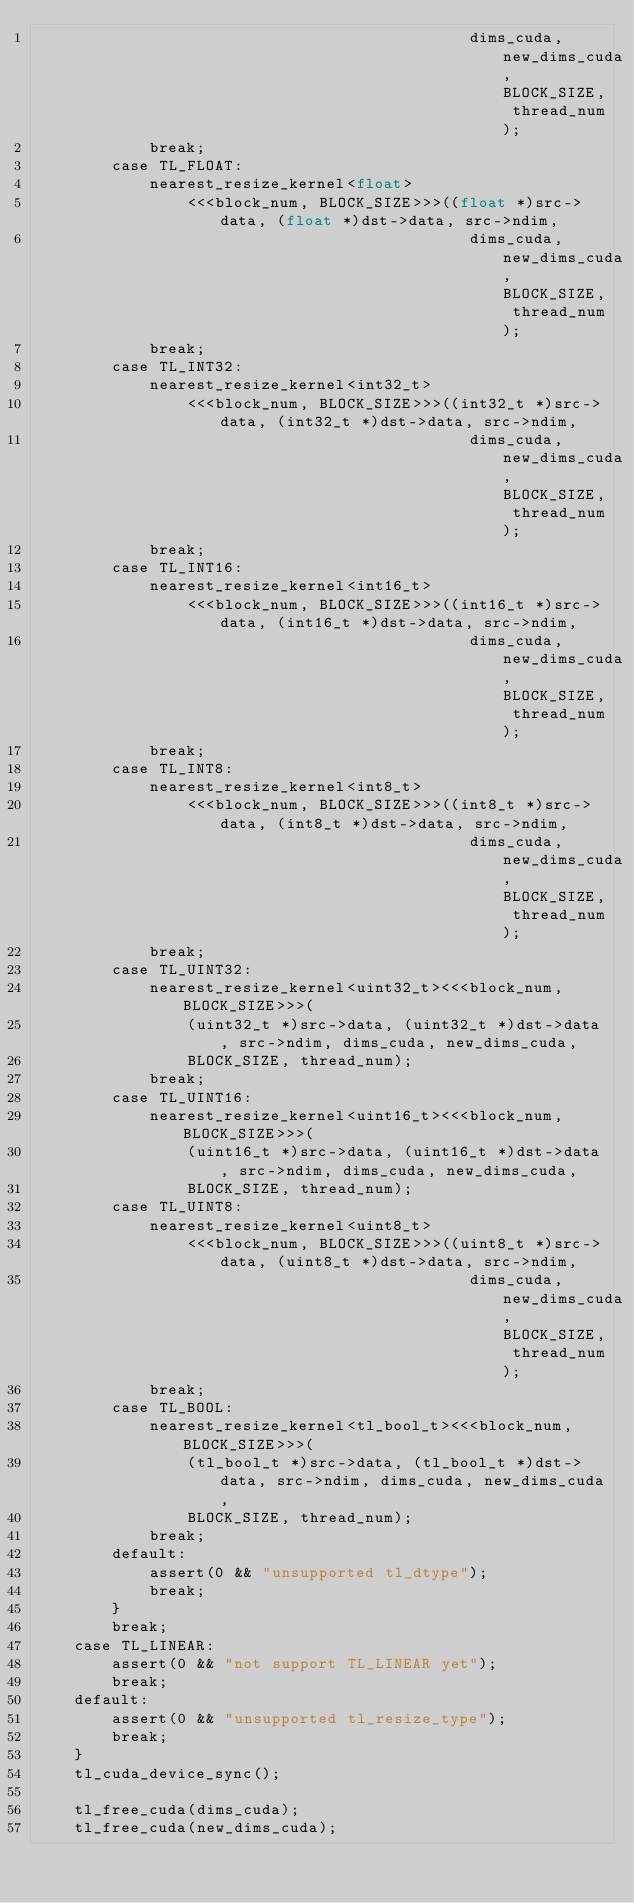Convert code to text. <code><loc_0><loc_0><loc_500><loc_500><_Cuda_>                                              dims_cuda, new_dims_cuda, BLOCK_SIZE, thread_num);
            break;
        case TL_FLOAT:
            nearest_resize_kernel<float>
                <<<block_num, BLOCK_SIZE>>>((float *)src->data, (float *)dst->data, src->ndim,
                                              dims_cuda, new_dims_cuda, BLOCK_SIZE, thread_num);
            break;
        case TL_INT32:
            nearest_resize_kernel<int32_t>
                <<<block_num, BLOCK_SIZE>>>((int32_t *)src->data, (int32_t *)dst->data, src->ndim,
                                              dims_cuda, new_dims_cuda, BLOCK_SIZE, thread_num);
            break;
        case TL_INT16:
            nearest_resize_kernel<int16_t>
                <<<block_num, BLOCK_SIZE>>>((int16_t *)src->data, (int16_t *)dst->data, src->ndim,
                                              dims_cuda, new_dims_cuda, BLOCK_SIZE, thread_num);
            break;
        case TL_INT8:
            nearest_resize_kernel<int8_t>
                <<<block_num, BLOCK_SIZE>>>((int8_t *)src->data, (int8_t *)dst->data, src->ndim,
                                              dims_cuda, new_dims_cuda, BLOCK_SIZE, thread_num);
            break;
        case TL_UINT32:
            nearest_resize_kernel<uint32_t><<<block_num, BLOCK_SIZE>>>(
                (uint32_t *)src->data, (uint32_t *)dst->data, src->ndim, dims_cuda, new_dims_cuda,
                BLOCK_SIZE, thread_num);
            break;
        case TL_UINT16:
            nearest_resize_kernel<uint16_t><<<block_num, BLOCK_SIZE>>>(
                (uint16_t *)src->data, (uint16_t *)dst->data, src->ndim, dims_cuda, new_dims_cuda,
                BLOCK_SIZE, thread_num);
        case TL_UINT8:
            nearest_resize_kernel<uint8_t>
                <<<block_num, BLOCK_SIZE>>>((uint8_t *)src->data, (uint8_t *)dst->data, src->ndim,
                                              dims_cuda, new_dims_cuda, BLOCK_SIZE, thread_num);
            break;
        case TL_BOOL:
            nearest_resize_kernel<tl_bool_t><<<block_num, BLOCK_SIZE>>>(
                (tl_bool_t *)src->data, (tl_bool_t *)dst->data, src->ndim, dims_cuda, new_dims_cuda,
                BLOCK_SIZE, thread_num);
            break;
        default:
            assert(0 && "unsupported tl_dtype");
            break;
        }
        break;
    case TL_LINEAR:
        assert(0 && "not support TL_LINEAR yet");
        break;
    default:
        assert(0 && "unsupported tl_resize_type");
        break;
    }
    tl_cuda_device_sync();

    tl_free_cuda(dims_cuda);
    tl_free_cuda(new_dims_cuda);</code> 